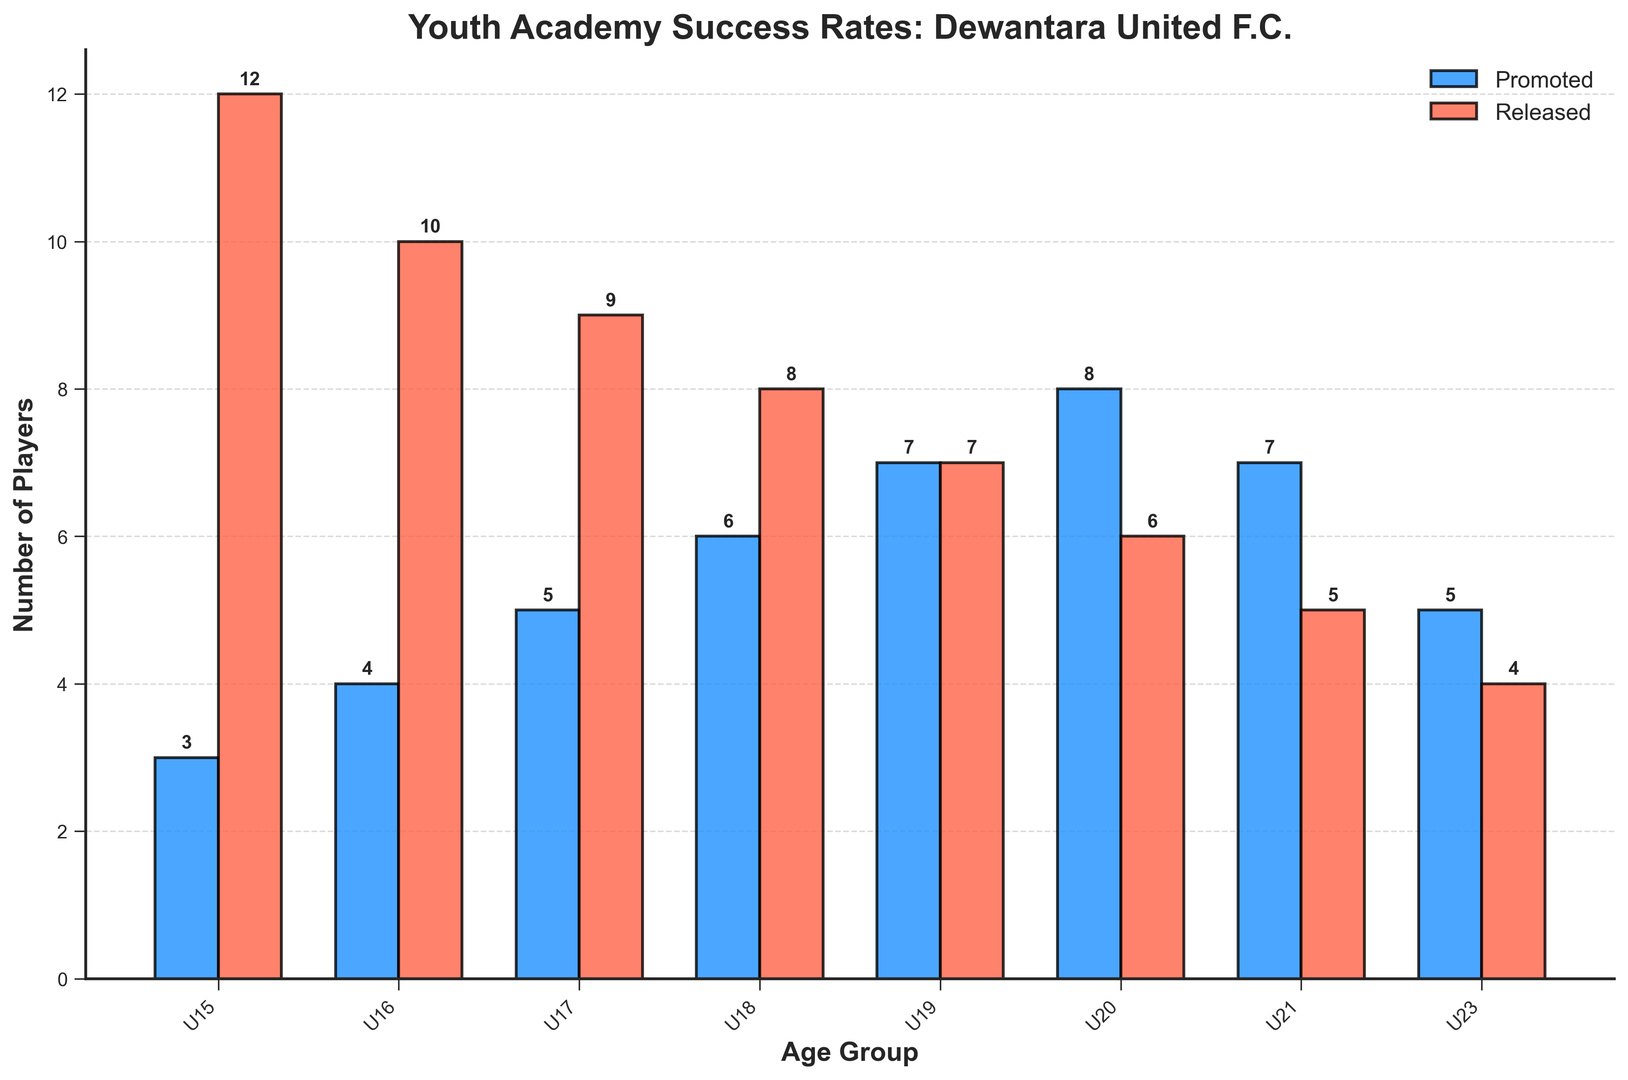What's the highest number of players promoted in any age group? Look at all the blue bars representing promoted players and identify the tallest one. The tallest blue bar is next to the U20 age group with a height of 8.
Answer: 8 Which age group has an equal number of players promoted and released? Look for the age groups where the blue and red bars are of equal height. The U19 age group has both blue and red bars of height 7.
Answer: U19 What is the total number of players released from U15 to U20? Add the heights of the red bars from U15 to U20. 12 + 10 + 9 + 8 + 7 + 6 = 52
Answer: 52 Which age group has the majority of players released compared to promoted? Check where the height of the red bar is significantly higher than the blue bar. The U15 age group has a red bar (12) that is higher than the blue bar (3).
Answer: U15 What is the average number of players promoted across all age groups? Add the heights of all the blue bars and divide by the number of age groups. (3 + 4 + 5 + 6 + 7 + 8 + 7 + 5) / 8 = 45 / 8 = 5.625
Answer: 5.625 How many players were promoted from U21 and U23 combined? Add the heights of the blue bars next to U21 and U23. 7 (U21) + 5 (U23) = 12
Answer: 12 Which age group had the least number of players promoted? Look for the shortest blue bar. The shortest blue bar is next to U15 with a height of 3.
Answer: U15 By how much does the number of players released from U18 exceed the number of players promoted from U18? Subtract the height of the blue bar from the red bar for U18. 8 (released) - 6 (promoted) = 2
Answer: 2 Which age group has the smallest difference between the number of players promoted and released? Calculate the differences for each age group and find the smallest. U23 1, U21 2, U20 2, U19 0, U18 2, U17 4, U16 6, U15 9. The smallest difference is 0, which is for U19.
Answer: U19 What is the sum of the number of players promoted in U16 and released in U16? Add the heights of the blue bar and the red bar for U16. 4 (promoted) + 10 (released) = 14
Answer: 14 